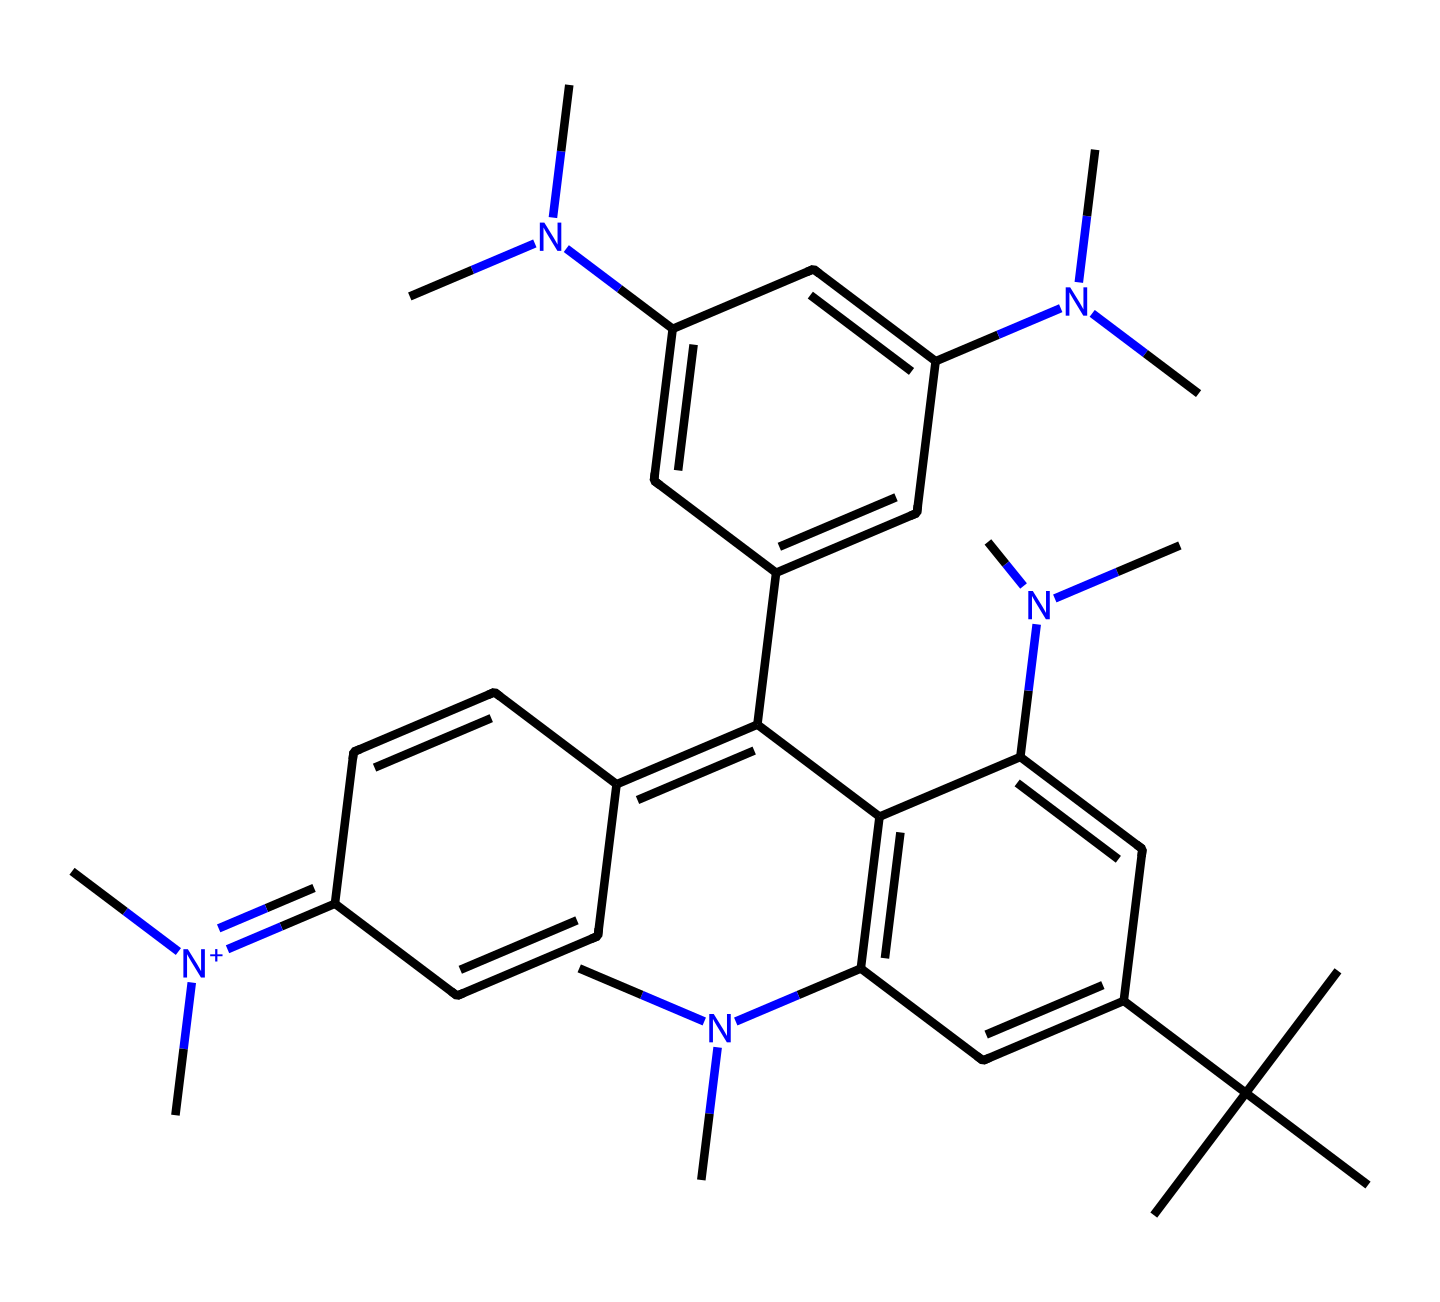What is the name of this chemical? The chemical structure provided is known as crystal violet, commonly used as a dye. The name can be derived from recognizing specific atom arrangements and functional groups typical of this dye.
Answer: crystal violet How many nitrogen atoms are present in this structure? By examining the SMILES notation, we can identify all the nitrogen (N) atoms marked in the structure. There are a total of six nitrogen atoms in the molecule.
Answer: six What is the color of crystal violet? Crystal violet is known for its deep purple color, which is characteristic of many dyes in the triphenylmethane class to which it belongs.
Answer: purple Is this chemical a cationic dye? Yes, crystal violet is considered a cationic dye due to the presence of a positive charge associated with its nitrogen atoms, which generally contribute to its dyeing properties.
Answer: yes What type of chemical structure does crystal violet belong to? Crystal violet belongs to the class of triphenylmethane dyes, which are often characterized by their structure that contains a central carbon atom bonded to three aromatic rings.
Answer: triphenylmethane What is the primary use of crystal violet in elections? Crystal violet is primarily used as secure voting ink in elections to prevent ballot tampering due to its long-lasting properties and visibility.
Answer: secure voting ink 